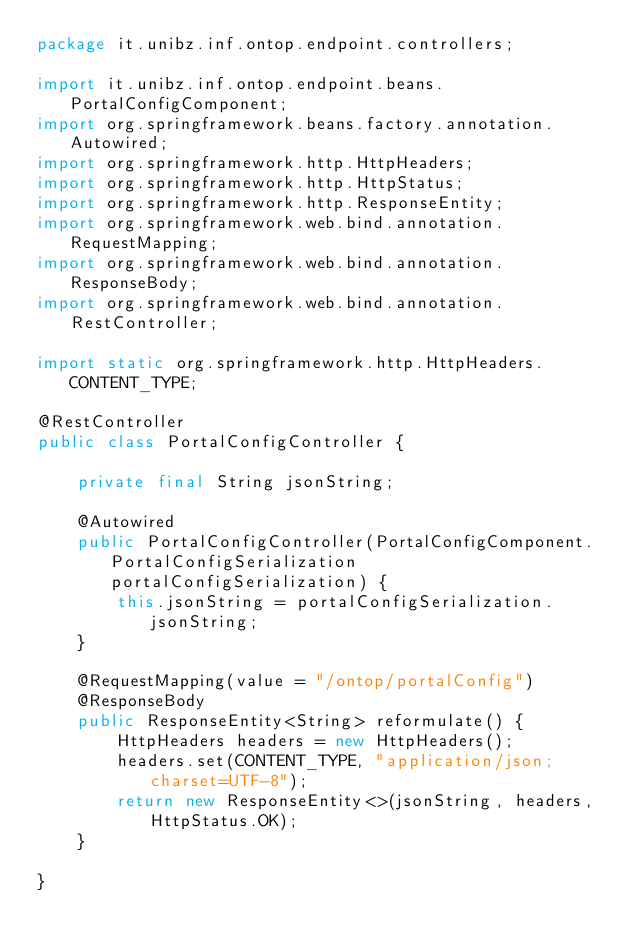Convert code to text. <code><loc_0><loc_0><loc_500><loc_500><_Java_>package it.unibz.inf.ontop.endpoint.controllers;

import it.unibz.inf.ontop.endpoint.beans.PortalConfigComponent;
import org.springframework.beans.factory.annotation.Autowired;
import org.springframework.http.HttpHeaders;
import org.springframework.http.HttpStatus;
import org.springframework.http.ResponseEntity;
import org.springframework.web.bind.annotation.RequestMapping;
import org.springframework.web.bind.annotation.ResponseBody;
import org.springframework.web.bind.annotation.RestController;

import static org.springframework.http.HttpHeaders.CONTENT_TYPE;

@RestController
public class PortalConfigController {

    private final String jsonString;

    @Autowired
    public PortalConfigController(PortalConfigComponent.PortalConfigSerialization portalConfigSerialization) {
        this.jsonString = portalConfigSerialization.jsonString;
    }

    @RequestMapping(value = "/ontop/portalConfig")
    @ResponseBody
    public ResponseEntity<String> reformulate() {
        HttpHeaders headers = new HttpHeaders();
        headers.set(CONTENT_TYPE, "application/json; charset=UTF-8");
        return new ResponseEntity<>(jsonString, headers, HttpStatus.OK);
    }

}
</code> 